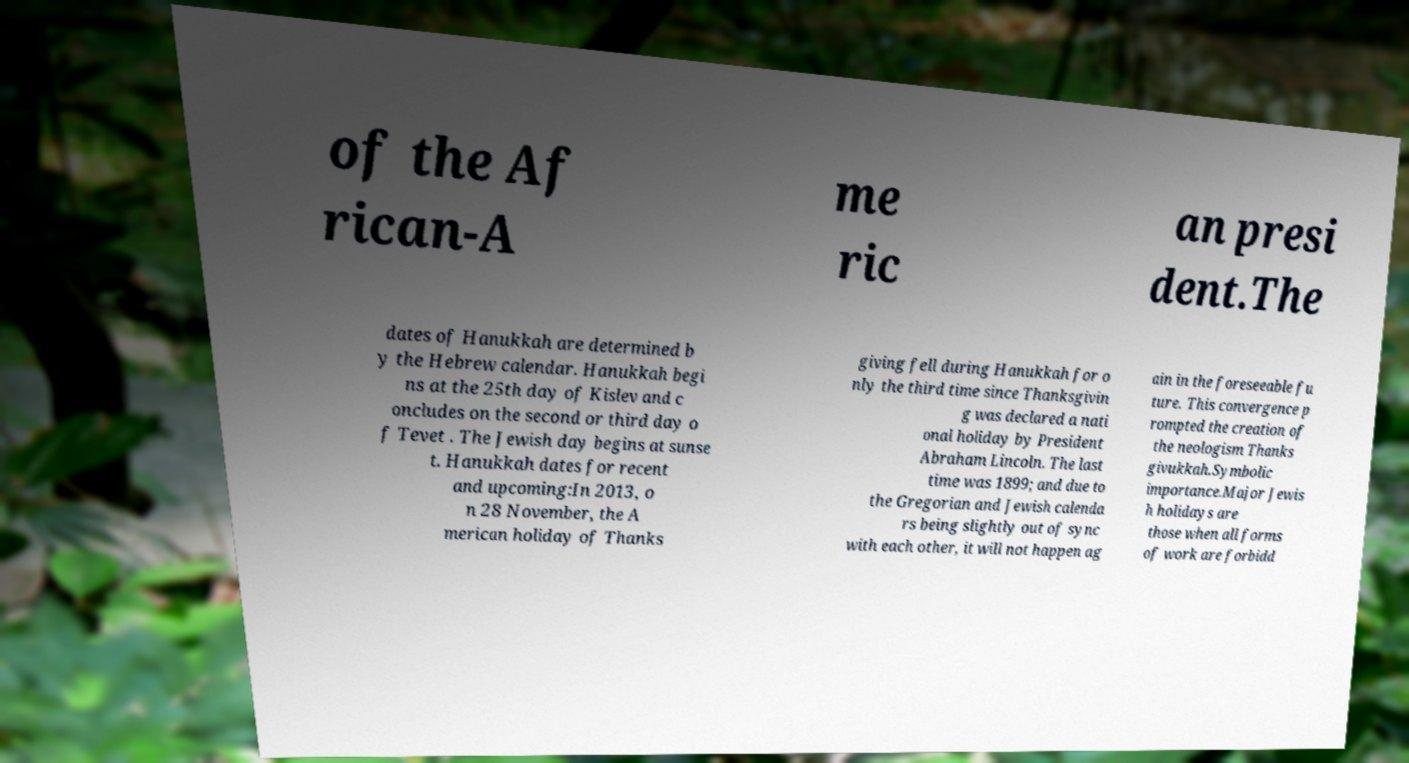Can you accurately transcribe the text from the provided image for me? of the Af rican-A me ric an presi dent.The dates of Hanukkah are determined b y the Hebrew calendar. Hanukkah begi ns at the 25th day of Kislev and c oncludes on the second or third day o f Tevet . The Jewish day begins at sunse t. Hanukkah dates for recent and upcoming:In 2013, o n 28 November, the A merican holiday of Thanks giving fell during Hanukkah for o nly the third time since Thanksgivin g was declared a nati onal holiday by President Abraham Lincoln. The last time was 1899; and due to the Gregorian and Jewish calenda rs being slightly out of sync with each other, it will not happen ag ain in the foreseeable fu ture. This convergence p rompted the creation of the neologism Thanks givukkah.Symbolic importance.Major Jewis h holidays are those when all forms of work are forbidd 